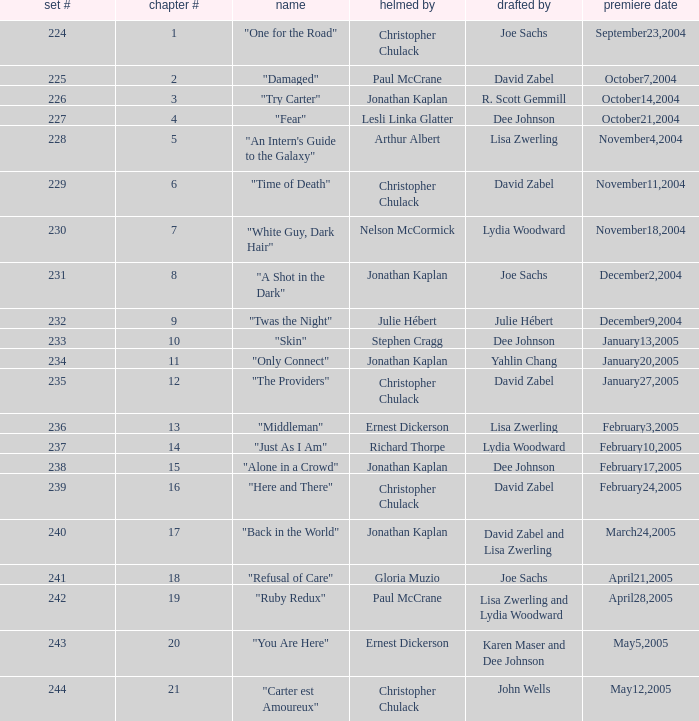Name who directed the episode for the series number 236 Ernest Dickerson. 